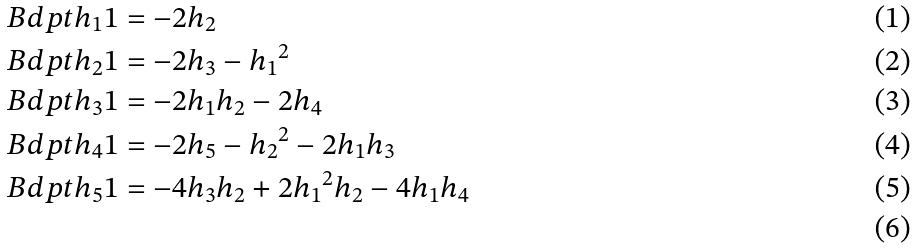Convert formula to latex. <formula><loc_0><loc_0><loc_500><loc_500>& \ B d p t { h _ { 1 } } 1 = - 2 h _ { 2 } \\ & \ B d p t { h _ { 2 } } 1 = - 2 h _ { 3 } - { h _ { 1 } } ^ { 2 } \\ & \ B d p t { h _ { 3 } } 1 = - 2 h _ { 1 } h _ { 2 } - 2 h _ { 4 } \\ & \ B d p t { h _ { 4 } } 1 = - 2 h _ { 5 } - { h _ { 2 } } ^ { 2 } - 2 h _ { 1 } h _ { 3 } \\ & \ B d p t { h _ { 5 } } 1 = - 4 h _ { 3 } h _ { 2 } + 2 { h _ { 1 } } ^ { 2 } h _ { 2 } - 4 h _ { 1 } h _ { 4 } \\</formula> 